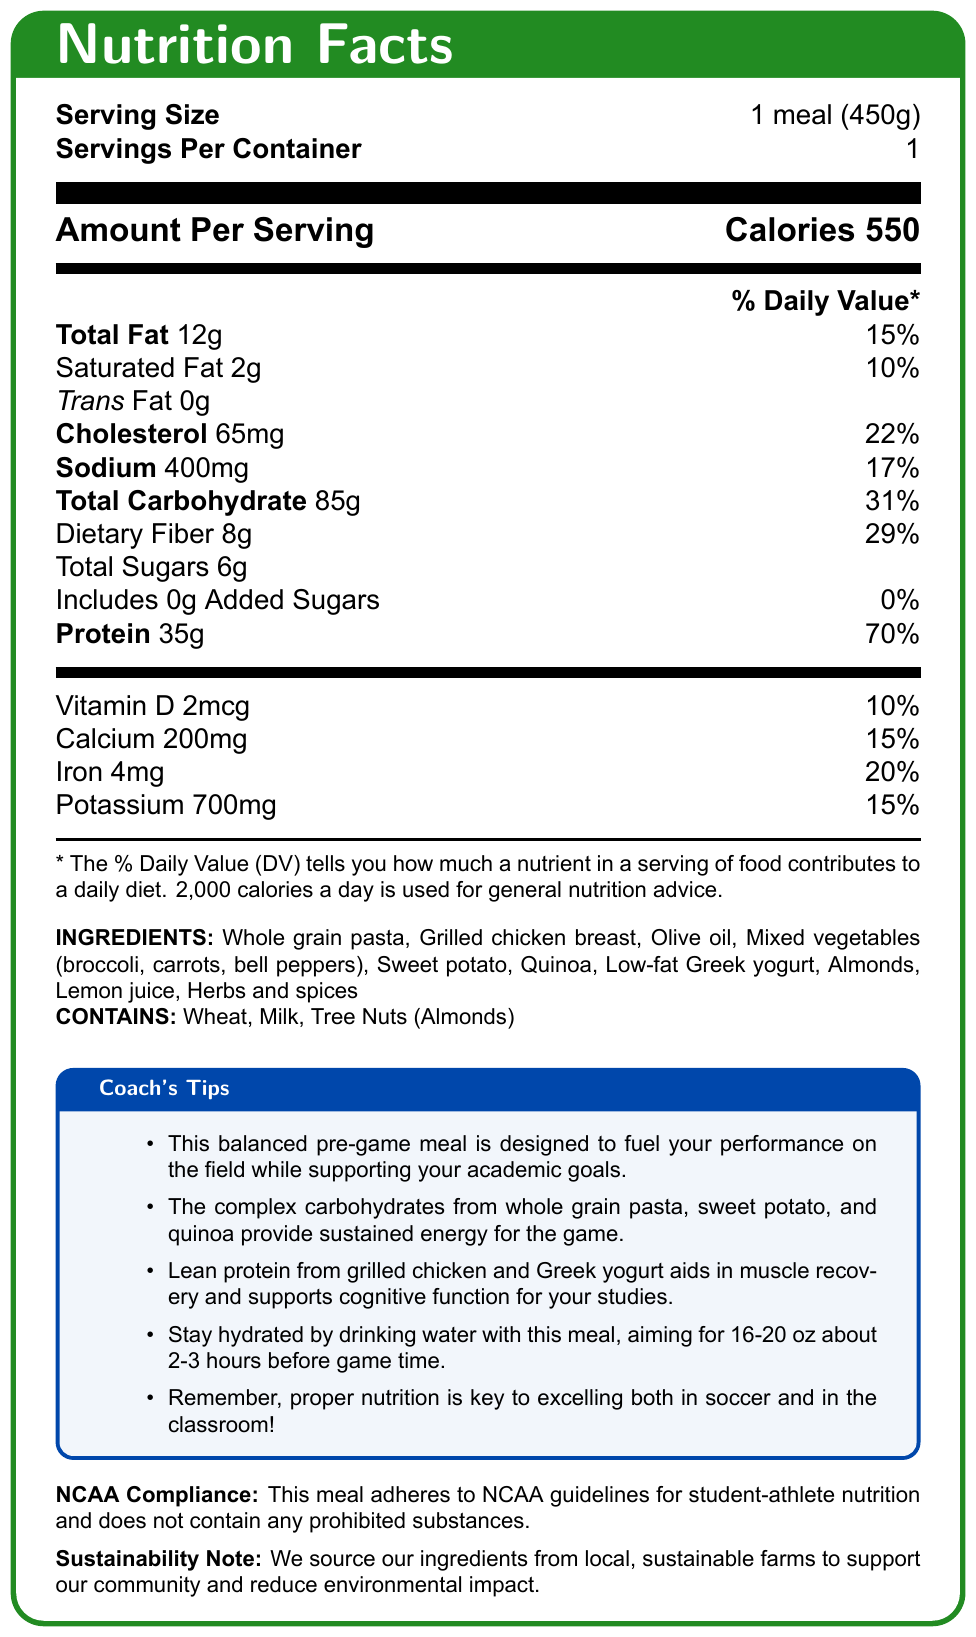what is the serving size? The serving size is clearly stated at the beginning of the document under the "Serving Size" section.
Answer: 1 meal (450g) how many calories are in one serving? The calories per serving are mentioned at the top section under "Amount Per Serving."
Answer: 550 how much protein is in the meal? The protein content is listed in the nutrition information, showing 35g per serving.
Answer: 35g which ingredients provide complex carbohydrates in this meal? The coach's tips section mentions that whole grain pasta, sweet potato, and quinoa provide complex carbohydrates.
Answer: Whole grain pasta, Sweet potato, Quinoa what is the total fat percentage of the daily value in this meal? The total fat percentage of the daily value is listed in the nutrition information as 15%.
Answer: 15% how much sodium does this meal contain? The sodium content is found in the nutrition facts, showing 400mg per serving.
Answer: 400mg which vitamins and minerals are mentioned in the nutrition information? The document lists Vitamin D, Calcium, Iron, and Potassium with their respective daily values.
Answer: Vitamin D, Calcium, Iron, Potassium what allergens are present in this meal? A. Wheat, Milk, Soy B. Tree Nuts, Milk, Peanuts C. Wheat, Milk, Tree Nuts D. Eggs, Wheat, Milk The document lists the allergens as Wheat, Milk, and Tree Nuts.
Answer: C which of the following best describes the purpose of this meal? A. Weight loss B. Fuel for performance and academic support C. Post-game recovery D. General nutrition The purpose is emphasized in the "Coach's Tips" stating that the meal is designed to fuel performance on the field and support academic goals.
Answer: B does this meal adhere to NCAA guidelines for student-athlete nutrition? The document explicitly states that the meal adheres to NCAA guidelines for student-athlete nutrition.
Answer: Yes summarize the main idea of the document. The document outlines the nutritional content, ingredients, and purpose of the meal, alongside compliance and sustainability notes.
Answer: This document provides nutrition facts and guidance for a balanced pre-game meal designed for college soccer players. The meal includes complex carbohydrates and lean proteins to fuel performance and support academic goals, adheres to NCAA guidelines, and is sustainably sourced. what are the vitamin D and calcium percentages of the daily value? Both percentages are listed under the vitamin and mineral section of the nutrition facts.
Answer: Vitamin D: 10%, Calcium: 15% what is the main source of lean protein in this meal? According to the "Coach's Tips," lean protein from grilled chicken aids muscle recovery.
Answer: Grilled chicken breast how long before game time should you drink water with this meal? The "Coach's Tips" suggests staying hydrated by drinking water 16-20 oz about 2-3 hours before game time.
Answer: 2-3 hours does the document specify the exact amounts of herbs and spices used? The document mentions herbs and spices in the ingredients list but does not specify the exact amounts.
Answer: No what ingredients might cause an allergic reaction for some people? The allergens listed are Wheat, Milk, and Tree Nuts (Almonds), which could cause allergic reactions.
Answer: Wheat, Milk, Almonds 